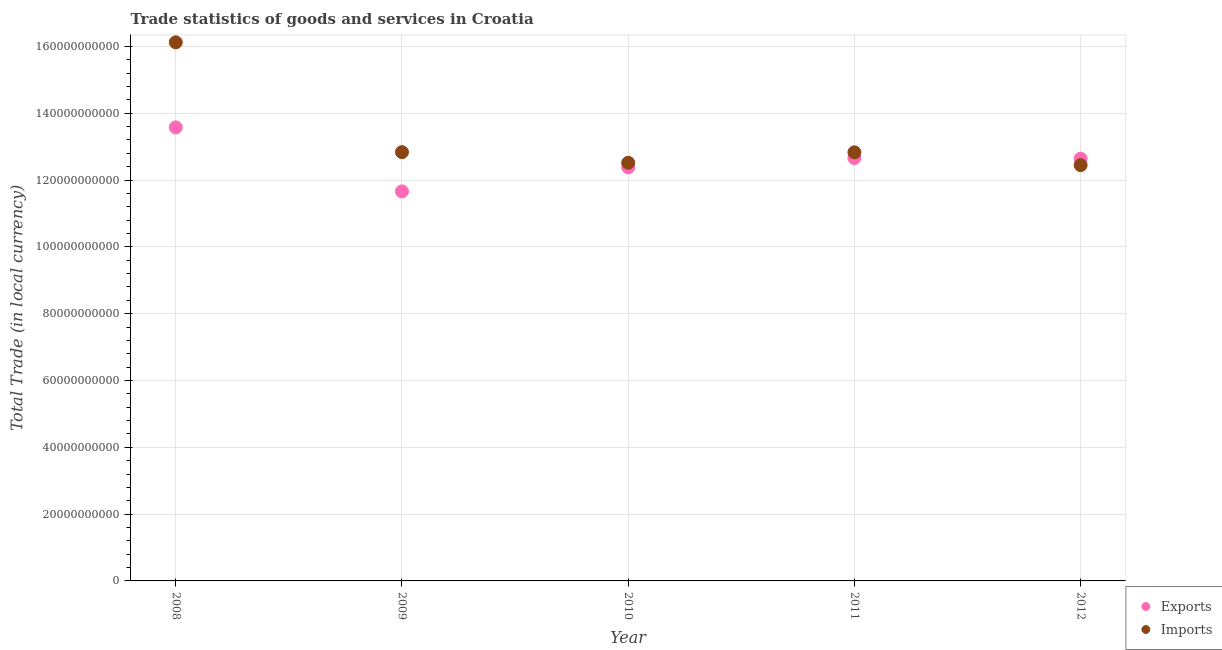Is the number of dotlines equal to the number of legend labels?
Keep it short and to the point. Yes. What is the imports of goods and services in 2008?
Your answer should be compact. 1.61e+11. Across all years, what is the maximum export of goods and services?
Offer a very short reply. 1.36e+11. Across all years, what is the minimum export of goods and services?
Offer a very short reply. 1.17e+11. In which year was the imports of goods and services maximum?
Offer a very short reply. 2008. What is the total imports of goods and services in the graph?
Your response must be concise. 6.68e+11. What is the difference between the export of goods and services in 2011 and that in 2012?
Offer a terse response. 1.83e+08. What is the difference between the imports of goods and services in 2010 and the export of goods and services in 2012?
Offer a very short reply. -1.21e+09. What is the average export of goods and services per year?
Keep it short and to the point. 1.26e+11. In the year 2008, what is the difference between the imports of goods and services and export of goods and services?
Your response must be concise. 2.55e+1. What is the ratio of the imports of goods and services in 2008 to that in 2012?
Make the answer very short. 1.3. Is the imports of goods and services in 2008 less than that in 2010?
Provide a succinct answer. No. Is the difference between the export of goods and services in 2010 and 2012 greater than the difference between the imports of goods and services in 2010 and 2012?
Your answer should be very brief. No. What is the difference between the highest and the second highest imports of goods and services?
Give a very brief answer. 3.29e+1. What is the difference between the highest and the lowest export of goods and services?
Give a very brief answer. 1.92e+1. Is the sum of the imports of goods and services in 2011 and 2012 greater than the maximum export of goods and services across all years?
Provide a short and direct response. Yes. Is the imports of goods and services strictly greater than the export of goods and services over the years?
Provide a succinct answer. No. How many dotlines are there?
Your answer should be very brief. 2. How many years are there in the graph?
Your answer should be compact. 5. What is the difference between two consecutive major ticks on the Y-axis?
Offer a very short reply. 2.00e+1. Are the values on the major ticks of Y-axis written in scientific E-notation?
Provide a short and direct response. No. Does the graph contain any zero values?
Ensure brevity in your answer.  No. Does the graph contain grids?
Offer a very short reply. Yes. What is the title of the graph?
Give a very brief answer. Trade statistics of goods and services in Croatia. Does "Borrowers" appear as one of the legend labels in the graph?
Offer a very short reply. No. What is the label or title of the Y-axis?
Make the answer very short. Total Trade (in local currency). What is the Total Trade (in local currency) of Exports in 2008?
Provide a succinct answer. 1.36e+11. What is the Total Trade (in local currency) in Imports in 2008?
Provide a short and direct response. 1.61e+11. What is the Total Trade (in local currency) in Exports in 2009?
Provide a succinct answer. 1.17e+11. What is the Total Trade (in local currency) of Imports in 2009?
Your answer should be compact. 1.28e+11. What is the Total Trade (in local currency) of Exports in 2010?
Your response must be concise. 1.24e+11. What is the Total Trade (in local currency) in Imports in 2010?
Keep it short and to the point. 1.25e+11. What is the Total Trade (in local currency) in Exports in 2011?
Provide a succinct answer. 1.27e+11. What is the Total Trade (in local currency) of Imports in 2011?
Provide a succinct answer. 1.28e+11. What is the Total Trade (in local currency) of Exports in 2012?
Offer a terse response. 1.26e+11. What is the Total Trade (in local currency) in Imports in 2012?
Offer a terse response. 1.24e+11. Across all years, what is the maximum Total Trade (in local currency) in Exports?
Offer a very short reply. 1.36e+11. Across all years, what is the maximum Total Trade (in local currency) of Imports?
Make the answer very short. 1.61e+11. Across all years, what is the minimum Total Trade (in local currency) of Exports?
Your answer should be very brief. 1.17e+11. Across all years, what is the minimum Total Trade (in local currency) in Imports?
Keep it short and to the point. 1.24e+11. What is the total Total Trade (in local currency) of Exports in the graph?
Ensure brevity in your answer.  6.29e+11. What is the total Total Trade (in local currency) of Imports in the graph?
Your answer should be compact. 6.68e+11. What is the difference between the Total Trade (in local currency) in Exports in 2008 and that in 2009?
Offer a terse response. 1.92e+1. What is the difference between the Total Trade (in local currency) of Imports in 2008 and that in 2009?
Keep it short and to the point. 3.29e+1. What is the difference between the Total Trade (in local currency) in Exports in 2008 and that in 2010?
Offer a terse response. 1.20e+1. What is the difference between the Total Trade (in local currency) of Imports in 2008 and that in 2010?
Offer a very short reply. 3.60e+1. What is the difference between the Total Trade (in local currency) of Exports in 2008 and that in 2011?
Give a very brief answer. 9.19e+09. What is the difference between the Total Trade (in local currency) of Imports in 2008 and that in 2011?
Your response must be concise. 3.29e+1. What is the difference between the Total Trade (in local currency) in Exports in 2008 and that in 2012?
Provide a succinct answer. 9.37e+09. What is the difference between the Total Trade (in local currency) in Imports in 2008 and that in 2012?
Offer a very short reply. 3.68e+1. What is the difference between the Total Trade (in local currency) of Exports in 2009 and that in 2010?
Your answer should be very brief. -7.19e+09. What is the difference between the Total Trade (in local currency) in Imports in 2009 and that in 2010?
Make the answer very short. 3.17e+09. What is the difference between the Total Trade (in local currency) of Exports in 2009 and that in 2011?
Ensure brevity in your answer.  -9.98e+09. What is the difference between the Total Trade (in local currency) in Imports in 2009 and that in 2011?
Keep it short and to the point. 5.20e+07. What is the difference between the Total Trade (in local currency) of Exports in 2009 and that in 2012?
Make the answer very short. -9.79e+09. What is the difference between the Total Trade (in local currency) in Imports in 2009 and that in 2012?
Make the answer very short. 3.88e+09. What is the difference between the Total Trade (in local currency) of Exports in 2010 and that in 2011?
Make the answer very short. -2.78e+09. What is the difference between the Total Trade (in local currency) in Imports in 2010 and that in 2011?
Your answer should be very brief. -3.12e+09. What is the difference between the Total Trade (in local currency) in Exports in 2010 and that in 2012?
Ensure brevity in your answer.  -2.60e+09. What is the difference between the Total Trade (in local currency) in Imports in 2010 and that in 2012?
Provide a succinct answer. 7.14e+08. What is the difference between the Total Trade (in local currency) of Exports in 2011 and that in 2012?
Your answer should be compact. 1.83e+08. What is the difference between the Total Trade (in local currency) in Imports in 2011 and that in 2012?
Provide a succinct answer. 3.83e+09. What is the difference between the Total Trade (in local currency) in Exports in 2008 and the Total Trade (in local currency) in Imports in 2009?
Your answer should be compact. 7.42e+09. What is the difference between the Total Trade (in local currency) in Exports in 2008 and the Total Trade (in local currency) in Imports in 2010?
Provide a short and direct response. 1.06e+1. What is the difference between the Total Trade (in local currency) of Exports in 2008 and the Total Trade (in local currency) of Imports in 2011?
Provide a succinct answer. 7.47e+09. What is the difference between the Total Trade (in local currency) of Exports in 2008 and the Total Trade (in local currency) of Imports in 2012?
Your answer should be very brief. 1.13e+1. What is the difference between the Total Trade (in local currency) of Exports in 2009 and the Total Trade (in local currency) of Imports in 2010?
Keep it short and to the point. -8.58e+09. What is the difference between the Total Trade (in local currency) of Exports in 2009 and the Total Trade (in local currency) of Imports in 2011?
Provide a short and direct response. -1.17e+1. What is the difference between the Total Trade (in local currency) in Exports in 2009 and the Total Trade (in local currency) in Imports in 2012?
Offer a very short reply. -7.86e+09. What is the difference between the Total Trade (in local currency) of Exports in 2010 and the Total Trade (in local currency) of Imports in 2011?
Offer a very short reply. -4.50e+09. What is the difference between the Total Trade (in local currency) of Exports in 2010 and the Total Trade (in local currency) of Imports in 2012?
Provide a succinct answer. -6.73e+08. What is the difference between the Total Trade (in local currency) of Exports in 2011 and the Total Trade (in local currency) of Imports in 2012?
Keep it short and to the point. 2.11e+09. What is the average Total Trade (in local currency) of Exports per year?
Give a very brief answer. 1.26e+11. What is the average Total Trade (in local currency) in Imports per year?
Provide a succinct answer. 1.34e+11. In the year 2008, what is the difference between the Total Trade (in local currency) in Exports and Total Trade (in local currency) in Imports?
Provide a succinct answer. -2.55e+1. In the year 2009, what is the difference between the Total Trade (in local currency) of Exports and Total Trade (in local currency) of Imports?
Keep it short and to the point. -1.17e+1. In the year 2010, what is the difference between the Total Trade (in local currency) of Exports and Total Trade (in local currency) of Imports?
Your answer should be compact. -1.39e+09. In the year 2011, what is the difference between the Total Trade (in local currency) of Exports and Total Trade (in local currency) of Imports?
Offer a terse response. -1.72e+09. In the year 2012, what is the difference between the Total Trade (in local currency) of Exports and Total Trade (in local currency) of Imports?
Keep it short and to the point. 1.93e+09. What is the ratio of the Total Trade (in local currency) of Exports in 2008 to that in 2009?
Keep it short and to the point. 1.16. What is the ratio of the Total Trade (in local currency) of Imports in 2008 to that in 2009?
Your answer should be very brief. 1.26. What is the ratio of the Total Trade (in local currency) in Exports in 2008 to that in 2010?
Your response must be concise. 1.1. What is the ratio of the Total Trade (in local currency) of Imports in 2008 to that in 2010?
Keep it short and to the point. 1.29. What is the ratio of the Total Trade (in local currency) of Exports in 2008 to that in 2011?
Your response must be concise. 1.07. What is the ratio of the Total Trade (in local currency) in Imports in 2008 to that in 2011?
Offer a very short reply. 1.26. What is the ratio of the Total Trade (in local currency) of Exports in 2008 to that in 2012?
Keep it short and to the point. 1.07. What is the ratio of the Total Trade (in local currency) in Imports in 2008 to that in 2012?
Keep it short and to the point. 1.3. What is the ratio of the Total Trade (in local currency) of Exports in 2009 to that in 2010?
Your response must be concise. 0.94. What is the ratio of the Total Trade (in local currency) in Imports in 2009 to that in 2010?
Give a very brief answer. 1.03. What is the ratio of the Total Trade (in local currency) in Exports in 2009 to that in 2011?
Provide a short and direct response. 0.92. What is the ratio of the Total Trade (in local currency) in Imports in 2009 to that in 2011?
Your response must be concise. 1. What is the ratio of the Total Trade (in local currency) of Exports in 2009 to that in 2012?
Keep it short and to the point. 0.92. What is the ratio of the Total Trade (in local currency) of Imports in 2009 to that in 2012?
Provide a succinct answer. 1.03. What is the ratio of the Total Trade (in local currency) of Exports in 2010 to that in 2011?
Offer a terse response. 0.98. What is the ratio of the Total Trade (in local currency) of Imports in 2010 to that in 2011?
Keep it short and to the point. 0.98. What is the ratio of the Total Trade (in local currency) in Exports in 2010 to that in 2012?
Give a very brief answer. 0.98. What is the ratio of the Total Trade (in local currency) of Exports in 2011 to that in 2012?
Ensure brevity in your answer.  1. What is the ratio of the Total Trade (in local currency) of Imports in 2011 to that in 2012?
Your answer should be compact. 1.03. What is the difference between the highest and the second highest Total Trade (in local currency) in Exports?
Provide a succinct answer. 9.19e+09. What is the difference between the highest and the second highest Total Trade (in local currency) of Imports?
Your response must be concise. 3.29e+1. What is the difference between the highest and the lowest Total Trade (in local currency) in Exports?
Provide a succinct answer. 1.92e+1. What is the difference between the highest and the lowest Total Trade (in local currency) in Imports?
Provide a succinct answer. 3.68e+1. 